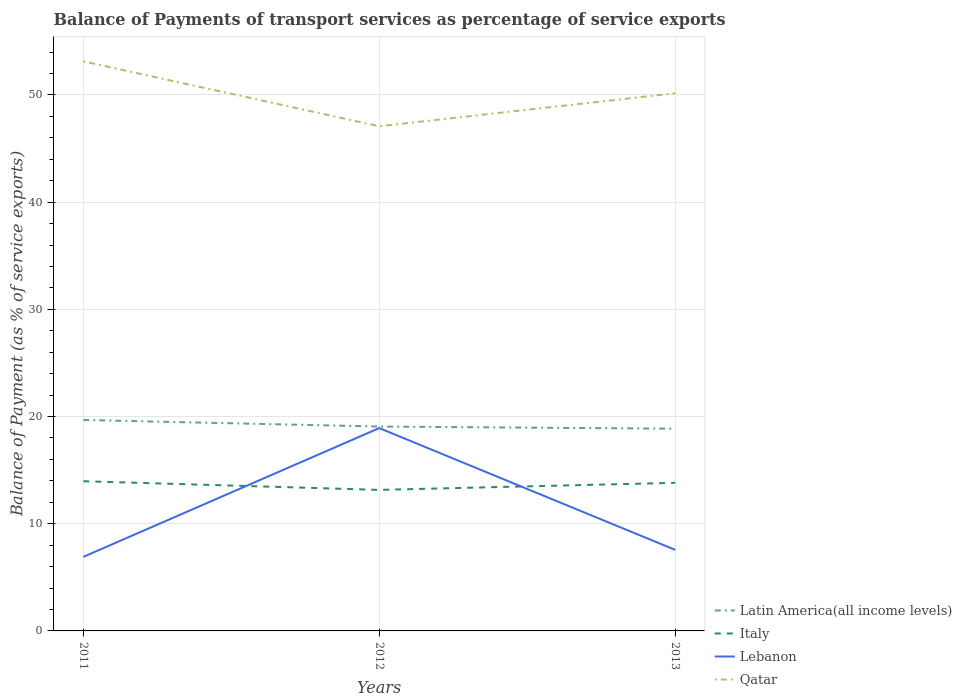How many different coloured lines are there?
Keep it short and to the point. 4. Does the line corresponding to Latin America(all income levels) intersect with the line corresponding to Lebanon?
Keep it short and to the point. No. Is the number of lines equal to the number of legend labels?
Offer a terse response. Yes. Across all years, what is the maximum balance of payments of transport services in Italy?
Your answer should be compact. 13.16. In which year was the balance of payments of transport services in Latin America(all income levels) maximum?
Make the answer very short. 2013. What is the total balance of payments of transport services in Qatar in the graph?
Provide a succinct answer. 2.98. What is the difference between the highest and the second highest balance of payments of transport services in Qatar?
Keep it short and to the point. 6.05. Is the balance of payments of transport services in Latin America(all income levels) strictly greater than the balance of payments of transport services in Lebanon over the years?
Offer a terse response. No. How many lines are there?
Ensure brevity in your answer.  4. How many years are there in the graph?
Provide a short and direct response. 3. Are the values on the major ticks of Y-axis written in scientific E-notation?
Your answer should be very brief. No. Does the graph contain grids?
Offer a very short reply. Yes. Where does the legend appear in the graph?
Give a very brief answer. Bottom right. How many legend labels are there?
Offer a very short reply. 4. How are the legend labels stacked?
Make the answer very short. Vertical. What is the title of the graph?
Provide a short and direct response. Balance of Payments of transport services as percentage of service exports. What is the label or title of the X-axis?
Provide a succinct answer. Years. What is the label or title of the Y-axis?
Provide a succinct answer. Balance of Payment (as % of service exports). What is the Balance of Payment (as % of service exports) in Latin America(all income levels) in 2011?
Provide a succinct answer. 19.68. What is the Balance of Payment (as % of service exports) of Italy in 2011?
Offer a very short reply. 13.96. What is the Balance of Payment (as % of service exports) in Lebanon in 2011?
Provide a short and direct response. 6.91. What is the Balance of Payment (as % of service exports) in Qatar in 2011?
Provide a short and direct response. 53.13. What is the Balance of Payment (as % of service exports) of Latin America(all income levels) in 2012?
Offer a terse response. 19.07. What is the Balance of Payment (as % of service exports) of Italy in 2012?
Give a very brief answer. 13.16. What is the Balance of Payment (as % of service exports) of Lebanon in 2012?
Provide a succinct answer. 18.92. What is the Balance of Payment (as % of service exports) of Qatar in 2012?
Your answer should be very brief. 47.08. What is the Balance of Payment (as % of service exports) of Latin America(all income levels) in 2013?
Your answer should be very brief. 18.86. What is the Balance of Payment (as % of service exports) in Italy in 2013?
Keep it short and to the point. 13.82. What is the Balance of Payment (as % of service exports) of Lebanon in 2013?
Offer a terse response. 7.56. What is the Balance of Payment (as % of service exports) in Qatar in 2013?
Your answer should be very brief. 50.16. Across all years, what is the maximum Balance of Payment (as % of service exports) of Latin America(all income levels)?
Your answer should be compact. 19.68. Across all years, what is the maximum Balance of Payment (as % of service exports) in Italy?
Make the answer very short. 13.96. Across all years, what is the maximum Balance of Payment (as % of service exports) of Lebanon?
Keep it short and to the point. 18.92. Across all years, what is the maximum Balance of Payment (as % of service exports) of Qatar?
Make the answer very short. 53.13. Across all years, what is the minimum Balance of Payment (as % of service exports) of Latin America(all income levels)?
Offer a very short reply. 18.86. Across all years, what is the minimum Balance of Payment (as % of service exports) of Italy?
Your answer should be very brief. 13.16. Across all years, what is the minimum Balance of Payment (as % of service exports) of Lebanon?
Your answer should be compact. 6.91. Across all years, what is the minimum Balance of Payment (as % of service exports) of Qatar?
Provide a succinct answer. 47.08. What is the total Balance of Payment (as % of service exports) in Latin America(all income levels) in the graph?
Ensure brevity in your answer.  57.61. What is the total Balance of Payment (as % of service exports) of Italy in the graph?
Give a very brief answer. 40.94. What is the total Balance of Payment (as % of service exports) of Lebanon in the graph?
Keep it short and to the point. 33.39. What is the total Balance of Payment (as % of service exports) in Qatar in the graph?
Your answer should be very brief. 150.37. What is the difference between the Balance of Payment (as % of service exports) of Latin America(all income levels) in 2011 and that in 2012?
Keep it short and to the point. 0.61. What is the difference between the Balance of Payment (as % of service exports) of Italy in 2011 and that in 2012?
Make the answer very short. 0.81. What is the difference between the Balance of Payment (as % of service exports) in Lebanon in 2011 and that in 2012?
Provide a short and direct response. -12.01. What is the difference between the Balance of Payment (as % of service exports) of Qatar in 2011 and that in 2012?
Make the answer very short. 6.05. What is the difference between the Balance of Payment (as % of service exports) in Latin America(all income levels) in 2011 and that in 2013?
Your answer should be very brief. 0.81. What is the difference between the Balance of Payment (as % of service exports) in Italy in 2011 and that in 2013?
Keep it short and to the point. 0.15. What is the difference between the Balance of Payment (as % of service exports) in Lebanon in 2011 and that in 2013?
Provide a short and direct response. -0.65. What is the difference between the Balance of Payment (as % of service exports) of Qatar in 2011 and that in 2013?
Your answer should be very brief. 2.98. What is the difference between the Balance of Payment (as % of service exports) in Latin America(all income levels) in 2012 and that in 2013?
Your response must be concise. 0.2. What is the difference between the Balance of Payment (as % of service exports) of Italy in 2012 and that in 2013?
Make the answer very short. -0.66. What is the difference between the Balance of Payment (as % of service exports) in Lebanon in 2012 and that in 2013?
Your answer should be compact. 11.36. What is the difference between the Balance of Payment (as % of service exports) of Qatar in 2012 and that in 2013?
Provide a short and direct response. -3.08. What is the difference between the Balance of Payment (as % of service exports) in Latin America(all income levels) in 2011 and the Balance of Payment (as % of service exports) in Italy in 2012?
Your response must be concise. 6.52. What is the difference between the Balance of Payment (as % of service exports) in Latin America(all income levels) in 2011 and the Balance of Payment (as % of service exports) in Lebanon in 2012?
Your response must be concise. 0.76. What is the difference between the Balance of Payment (as % of service exports) in Latin America(all income levels) in 2011 and the Balance of Payment (as % of service exports) in Qatar in 2012?
Your response must be concise. -27.4. What is the difference between the Balance of Payment (as % of service exports) in Italy in 2011 and the Balance of Payment (as % of service exports) in Lebanon in 2012?
Keep it short and to the point. -4.96. What is the difference between the Balance of Payment (as % of service exports) of Italy in 2011 and the Balance of Payment (as % of service exports) of Qatar in 2012?
Keep it short and to the point. -33.12. What is the difference between the Balance of Payment (as % of service exports) in Lebanon in 2011 and the Balance of Payment (as % of service exports) in Qatar in 2012?
Offer a terse response. -40.17. What is the difference between the Balance of Payment (as % of service exports) in Latin America(all income levels) in 2011 and the Balance of Payment (as % of service exports) in Italy in 2013?
Your response must be concise. 5.86. What is the difference between the Balance of Payment (as % of service exports) of Latin America(all income levels) in 2011 and the Balance of Payment (as % of service exports) of Lebanon in 2013?
Your response must be concise. 12.12. What is the difference between the Balance of Payment (as % of service exports) of Latin America(all income levels) in 2011 and the Balance of Payment (as % of service exports) of Qatar in 2013?
Your answer should be very brief. -30.48. What is the difference between the Balance of Payment (as % of service exports) in Italy in 2011 and the Balance of Payment (as % of service exports) in Lebanon in 2013?
Provide a succinct answer. 6.4. What is the difference between the Balance of Payment (as % of service exports) of Italy in 2011 and the Balance of Payment (as % of service exports) of Qatar in 2013?
Make the answer very short. -36.19. What is the difference between the Balance of Payment (as % of service exports) of Lebanon in 2011 and the Balance of Payment (as % of service exports) of Qatar in 2013?
Keep it short and to the point. -43.25. What is the difference between the Balance of Payment (as % of service exports) of Latin America(all income levels) in 2012 and the Balance of Payment (as % of service exports) of Italy in 2013?
Offer a very short reply. 5.25. What is the difference between the Balance of Payment (as % of service exports) of Latin America(all income levels) in 2012 and the Balance of Payment (as % of service exports) of Lebanon in 2013?
Keep it short and to the point. 11.5. What is the difference between the Balance of Payment (as % of service exports) in Latin America(all income levels) in 2012 and the Balance of Payment (as % of service exports) in Qatar in 2013?
Offer a terse response. -31.09. What is the difference between the Balance of Payment (as % of service exports) in Italy in 2012 and the Balance of Payment (as % of service exports) in Lebanon in 2013?
Give a very brief answer. 5.59. What is the difference between the Balance of Payment (as % of service exports) in Italy in 2012 and the Balance of Payment (as % of service exports) in Qatar in 2013?
Ensure brevity in your answer.  -37. What is the difference between the Balance of Payment (as % of service exports) of Lebanon in 2012 and the Balance of Payment (as % of service exports) of Qatar in 2013?
Provide a succinct answer. -31.24. What is the average Balance of Payment (as % of service exports) in Latin America(all income levels) per year?
Your answer should be compact. 19.2. What is the average Balance of Payment (as % of service exports) of Italy per year?
Provide a short and direct response. 13.65. What is the average Balance of Payment (as % of service exports) of Lebanon per year?
Ensure brevity in your answer.  11.13. What is the average Balance of Payment (as % of service exports) of Qatar per year?
Provide a short and direct response. 50.12. In the year 2011, what is the difference between the Balance of Payment (as % of service exports) in Latin America(all income levels) and Balance of Payment (as % of service exports) in Italy?
Your answer should be very brief. 5.71. In the year 2011, what is the difference between the Balance of Payment (as % of service exports) in Latin America(all income levels) and Balance of Payment (as % of service exports) in Lebanon?
Your answer should be very brief. 12.77. In the year 2011, what is the difference between the Balance of Payment (as % of service exports) in Latin America(all income levels) and Balance of Payment (as % of service exports) in Qatar?
Offer a terse response. -33.45. In the year 2011, what is the difference between the Balance of Payment (as % of service exports) in Italy and Balance of Payment (as % of service exports) in Lebanon?
Provide a succinct answer. 7.06. In the year 2011, what is the difference between the Balance of Payment (as % of service exports) of Italy and Balance of Payment (as % of service exports) of Qatar?
Offer a terse response. -39.17. In the year 2011, what is the difference between the Balance of Payment (as % of service exports) of Lebanon and Balance of Payment (as % of service exports) of Qatar?
Ensure brevity in your answer.  -46.23. In the year 2012, what is the difference between the Balance of Payment (as % of service exports) of Latin America(all income levels) and Balance of Payment (as % of service exports) of Italy?
Ensure brevity in your answer.  5.91. In the year 2012, what is the difference between the Balance of Payment (as % of service exports) of Latin America(all income levels) and Balance of Payment (as % of service exports) of Lebanon?
Ensure brevity in your answer.  0.14. In the year 2012, what is the difference between the Balance of Payment (as % of service exports) in Latin America(all income levels) and Balance of Payment (as % of service exports) in Qatar?
Ensure brevity in your answer.  -28.01. In the year 2012, what is the difference between the Balance of Payment (as % of service exports) of Italy and Balance of Payment (as % of service exports) of Lebanon?
Keep it short and to the point. -5.76. In the year 2012, what is the difference between the Balance of Payment (as % of service exports) of Italy and Balance of Payment (as % of service exports) of Qatar?
Ensure brevity in your answer.  -33.92. In the year 2012, what is the difference between the Balance of Payment (as % of service exports) in Lebanon and Balance of Payment (as % of service exports) in Qatar?
Your response must be concise. -28.16. In the year 2013, what is the difference between the Balance of Payment (as % of service exports) in Latin America(all income levels) and Balance of Payment (as % of service exports) in Italy?
Give a very brief answer. 5.05. In the year 2013, what is the difference between the Balance of Payment (as % of service exports) of Latin America(all income levels) and Balance of Payment (as % of service exports) of Lebanon?
Offer a terse response. 11.3. In the year 2013, what is the difference between the Balance of Payment (as % of service exports) of Latin America(all income levels) and Balance of Payment (as % of service exports) of Qatar?
Offer a very short reply. -31.29. In the year 2013, what is the difference between the Balance of Payment (as % of service exports) in Italy and Balance of Payment (as % of service exports) in Lebanon?
Your response must be concise. 6.25. In the year 2013, what is the difference between the Balance of Payment (as % of service exports) of Italy and Balance of Payment (as % of service exports) of Qatar?
Ensure brevity in your answer.  -36.34. In the year 2013, what is the difference between the Balance of Payment (as % of service exports) in Lebanon and Balance of Payment (as % of service exports) in Qatar?
Provide a short and direct response. -42.59. What is the ratio of the Balance of Payment (as % of service exports) of Latin America(all income levels) in 2011 to that in 2012?
Provide a short and direct response. 1.03. What is the ratio of the Balance of Payment (as % of service exports) in Italy in 2011 to that in 2012?
Make the answer very short. 1.06. What is the ratio of the Balance of Payment (as % of service exports) of Lebanon in 2011 to that in 2012?
Your answer should be very brief. 0.37. What is the ratio of the Balance of Payment (as % of service exports) in Qatar in 2011 to that in 2012?
Ensure brevity in your answer.  1.13. What is the ratio of the Balance of Payment (as % of service exports) in Latin America(all income levels) in 2011 to that in 2013?
Offer a terse response. 1.04. What is the ratio of the Balance of Payment (as % of service exports) in Italy in 2011 to that in 2013?
Your answer should be very brief. 1.01. What is the ratio of the Balance of Payment (as % of service exports) in Lebanon in 2011 to that in 2013?
Make the answer very short. 0.91. What is the ratio of the Balance of Payment (as % of service exports) of Qatar in 2011 to that in 2013?
Keep it short and to the point. 1.06. What is the ratio of the Balance of Payment (as % of service exports) in Latin America(all income levels) in 2012 to that in 2013?
Your answer should be compact. 1.01. What is the ratio of the Balance of Payment (as % of service exports) in Italy in 2012 to that in 2013?
Your answer should be very brief. 0.95. What is the ratio of the Balance of Payment (as % of service exports) in Lebanon in 2012 to that in 2013?
Offer a very short reply. 2.5. What is the ratio of the Balance of Payment (as % of service exports) in Qatar in 2012 to that in 2013?
Your response must be concise. 0.94. What is the difference between the highest and the second highest Balance of Payment (as % of service exports) of Latin America(all income levels)?
Provide a succinct answer. 0.61. What is the difference between the highest and the second highest Balance of Payment (as % of service exports) of Italy?
Your response must be concise. 0.15. What is the difference between the highest and the second highest Balance of Payment (as % of service exports) of Lebanon?
Ensure brevity in your answer.  11.36. What is the difference between the highest and the second highest Balance of Payment (as % of service exports) in Qatar?
Give a very brief answer. 2.98. What is the difference between the highest and the lowest Balance of Payment (as % of service exports) of Latin America(all income levels)?
Make the answer very short. 0.81. What is the difference between the highest and the lowest Balance of Payment (as % of service exports) in Italy?
Offer a very short reply. 0.81. What is the difference between the highest and the lowest Balance of Payment (as % of service exports) in Lebanon?
Your answer should be very brief. 12.01. What is the difference between the highest and the lowest Balance of Payment (as % of service exports) in Qatar?
Offer a very short reply. 6.05. 